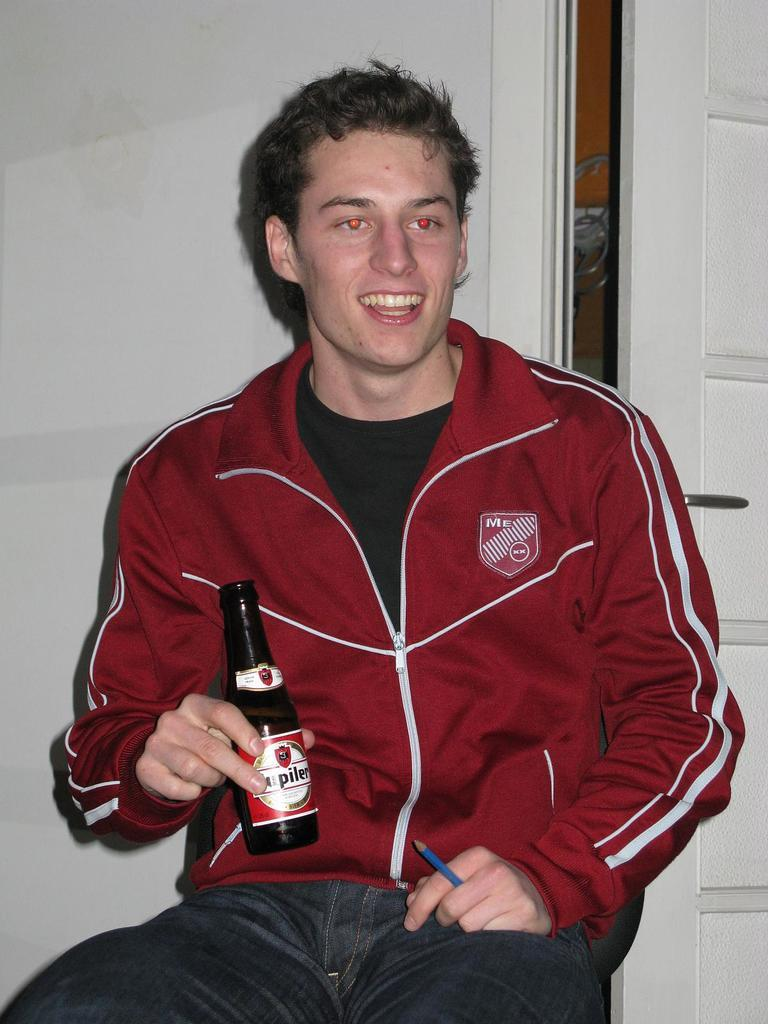What is the man in the image holding in his hand? The man is holding a bottle and a pencil in the image. Can you describe the objects the man is holding? The man is holding a bottle and a pencil, which are both long and thin objects. How many cakes can be seen on the table in the image? There is no table or cakes present in the image; it only features a man holding a bottle and a pencil. 